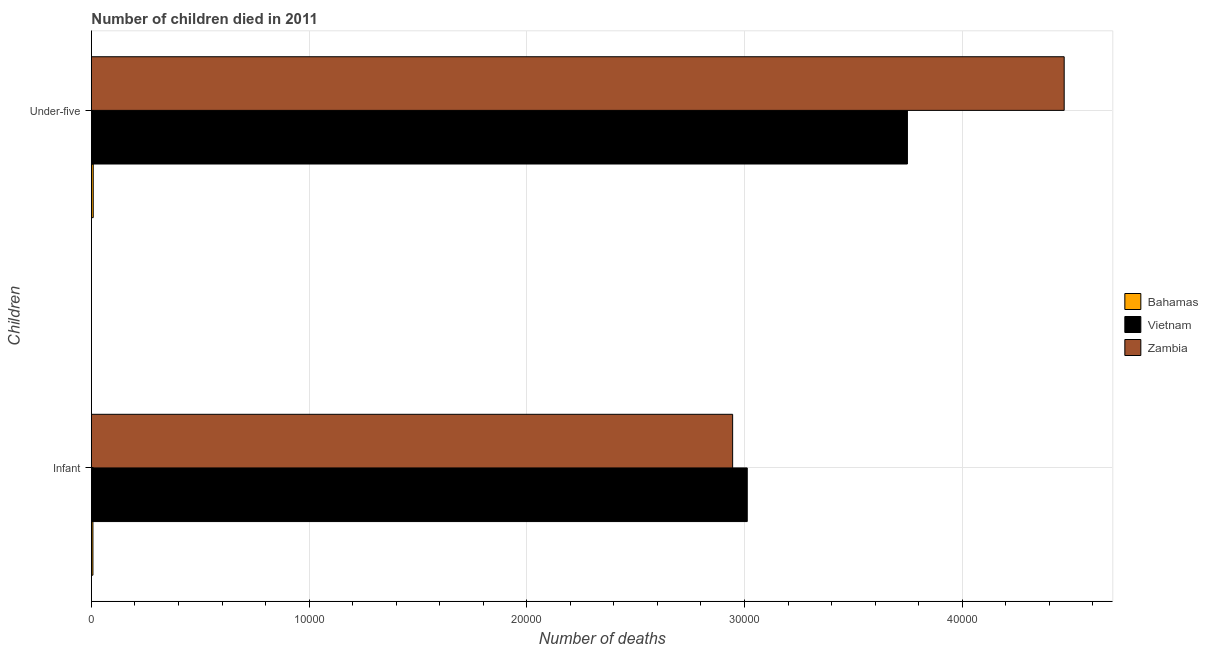How many different coloured bars are there?
Offer a very short reply. 3. Are the number of bars per tick equal to the number of legend labels?
Your answer should be very brief. Yes. How many bars are there on the 2nd tick from the top?
Keep it short and to the point. 3. What is the label of the 2nd group of bars from the top?
Offer a terse response. Infant. What is the number of under-five deaths in Vietnam?
Your response must be concise. 3.75e+04. Across all countries, what is the maximum number of under-five deaths?
Your answer should be very brief. 4.47e+04. Across all countries, what is the minimum number of under-five deaths?
Offer a very short reply. 83. In which country was the number of under-five deaths maximum?
Give a very brief answer. Zambia. In which country was the number of infant deaths minimum?
Your answer should be very brief. Bahamas. What is the total number of infant deaths in the graph?
Offer a very short reply. 5.96e+04. What is the difference between the number of infant deaths in Zambia and that in Vietnam?
Keep it short and to the point. -671. What is the difference between the number of under-five deaths in Bahamas and the number of infant deaths in Zambia?
Offer a very short reply. -2.94e+04. What is the average number of infant deaths per country?
Provide a short and direct response. 1.99e+04. What is the difference between the number of infant deaths and number of under-five deaths in Vietnam?
Offer a terse response. -7357. In how many countries, is the number of infant deaths greater than 28000 ?
Your answer should be very brief. 2. What is the ratio of the number of infant deaths in Zambia to that in Bahamas?
Your answer should be very brief. 426.87. Is the number of infant deaths in Zambia less than that in Vietnam?
Your answer should be very brief. Yes. What does the 3rd bar from the top in Infant represents?
Make the answer very short. Bahamas. What does the 3rd bar from the bottom in Infant represents?
Give a very brief answer. Zambia. How many bars are there?
Keep it short and to the point. 6. How many countries are there in the graph?
Your answer should be compact. 3. What is the difference between two consecutive major ticks on the X-axis?
Offer a terse response. 10000. Are the values on the major ticks of X-axis written in scientific E-notation?
Make the answer very short. No. Does the graph contain any zero values?
Offer a very short reply. No. Where does the legend appear in the graph?
Offer a terse response. Center right. What is the title of the graph?
Your answer should be very brief. Number of children died in 2011. Does "Malta" appear as one of the legend labels in the graph?
Give a very brief answer. No. What is the label or title of the X-axis?
Offer a terse response. Number of deaths. What is the label or title of the Y-axis?
Give a very brief answer. Children. What is the Number of deaths in Bahamas in Infant?
Your answer should be very brief. 69. What is the Number of deaths in Vietnam in Infant?
Offer a terse response. 3.01e+04. What is the Number of deaths in Zambia in Infant?
Make the answer very short. 2.95e+04. What is the Number of deaths in Bahamas in Under-five?
Your response must be concise. 83. What is the Number of deaths in Vietnam in Under-five?
Ensure brevity in your answer.  3.75e+04. What is the Number of deaths of Zambia in Under-five?
Ensure brevity in your answer.  4.47e+04. Across all Children, what is the maximum Number of deaths in Vietnam?
Your response must be concise. 3.75e+04. Across all Children, what is the maximum Number of deaths of Zambia?
Your answer should be very brief. 4.47e+04. Across all Children, what is the minimum Number of deaths in Bahamas?
Provide a succinct answer. 69. Across all Children, what is the minimum Number of deaths of Vietnam?
Your response must be concise. 3.01e+04. Across all Children, what is the minimum Number of deaths in Zambia?
Keep it short and to the point. 2.95e+04. What is the total Number of deaths in Bahamas in the graph?
Offer a terse response. 152. What is the total Number of deaths of Vietnam in the graph?
Offer a very short reply. 6.76e+04. What is the total Number of deaths of Zambia in the graph?
Provide a short and direct response. 7.41e+04. What is the difference between the Number of deaths of Bahamas in Infant and that in Under-five?
Provide a succinct answer. -14. What is the difference between the Number of deaths of Vietnam in Infant and that in Under-five?
Provide a short and direct response. -7357. What is the difference between the Number of deaths of Zambia in Infant and that in Under-five?
Your response must be concise. -1.52e+04. What is the difference between the Number of deaths in Bahamas in Infant and the Number of deaths in Vietnam in Under-five?
Make the answer very short. -3.74e+04. What is the difference between the Number of deaths in Bahamas in Infant and the Number of deaths in Zambia in Under-five?
Provide a short and direct response. -4.46e+04. What is the difference between the Number of deaths in Vietnam in Infant and the Number of deaths in Zambia in Under-five?
Ensure brevity in your answer.  -1.46e+04. What is the average Number of deaths in Bahamas per Children?
Ensure brevity in your answer.  76. What is the average Number of deaths in Vietnam per Children?
Provide a short and direct response. 3.38e+04. What is the average Number of deaths in Zambia per Children?
Your answer should be compact. 3.71e+04. What is the difference between the Number of deaths in Bahamas and Number of deaths in Vietnam in Infant?
Your answer should be compact. -3.01e+04. What is the difference between the Number of deaths of Bahamas and Number of deaths of Zambia in Infant?
Your answer should be very brief. -2.94e+04. What is the difference between the Number of deaths of Vietnam and Number of deaths of Zambia in Infant?
Offer a terse response. 671. What is the difference between the Number of deaths in Bahamas and Number of deaths in Vietnam in Under-five?
Offer a very short reply. -3.74e+04. What is the difference between the Number of deaths in Bahamas and Number of deaths in Zambia in Under-five?
Your answer should be compact. -4.46e+04. What is the difference between the Number of deaths of Vietnam and Number of deaths of Zambia in Under-five?
Provide a short and direct response. -7201. What is the ratio of the Number of deaths in Bahamas in Infant to that in Under-five?
Make the answer very short. 0.83. What is the ratio of the Number of deaths in Vietnam in Infant to that in Under-five?
Your answer should be very brief. 0.8. What is the ratio of the Number of deaths of Zambia in Infant to that in Under-five?
Ensure brevity in your answer.  0.66. What is the difference between the highest and the second highest Number of deaths of Bahamas?
Offer a terse response. 14. What is the difference between the highest and the second highest Number of deaths of Vietnam?
Offer a terse response. 7357. What is the difference between the highest and the second highest Number of deaths in Zambia?
Give a very brief answer. 1.52e+04. What is the difference between the highest and the lowest Number of deaths of Vietnam?
Offer a terse response. 7357. What is the difference between the highest and the lowest Number of deaths in Zambia?
Keep it short and to the point. 1.52e+04. 